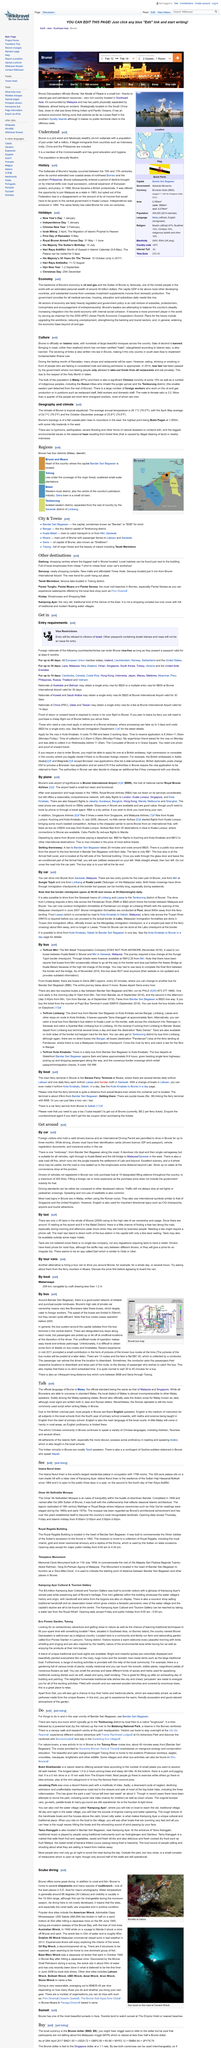Draw attention to some important aspects in this diagram. Gadong and Serusop are categorized as "other destinations The Tutong River is home to a diverse array of endemic wildlife, including proboscis monkeys, eagles, crocodiles, macaques, kingfishers, and many other species. According to the article 'Do,' eco-tours typically go to the Temburong district, specifically to areas with rich biodiversity and natural beauty, such as the mangrove forests and the Tamugan Conservation Area. I have discovered a new and exciting activity for nature lovers. The Tutong River cruise tour is an excellent opportunity to explore the beauty of nature while enjoying a leisurely boat ride. This tour takes you along the Tutong River, showcasing the stunning natural scenery and wildlife of Brunei. As a nature lover, I highly recommend this tour to anyone who wants to experience the wonder of the great outdoors. In 1888, Brunei became a British protectorate, marking the beginning of a long and significant relationship between the two nations. 